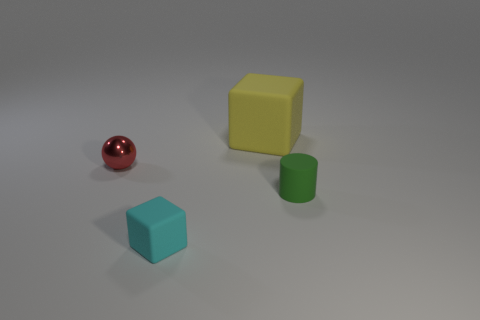There is a thing that is on the left side of the big yellow matte block and behind the small green matte cylinder; what material is it?
Give a very brief answer. Metal. Is the shape of the rubber thing behind the small ball the same as  the small green object?
Keep it short and to the point. No. Are there fewer large cubes than small purple matte cylinders?
Your answer should be very brief. No. What number of other rubber cylinders are the same color as the small cylinder?
Your response must be concise. 0. Is the number of large matte blocks greater than the number of small things?
Offer a terse response. No. The cyan thing that is the same shape as the large yellow object is what size?
Make the answer very short. Small. Does the small green object have the same material as the cube to the left of the large yellow matte object?
Your answer should be compact. Yes. What number of things are green objects or tiny cyan blocks?
Make the answer very short. 2. Is the size of the thing that is to the left of the cyan rubber thing the same as the rubber thing that is in front of the green thing?
Offer a terse response. Yes. How many cylinders are tiny objects or matte things?
Your response must be concise. 1. 